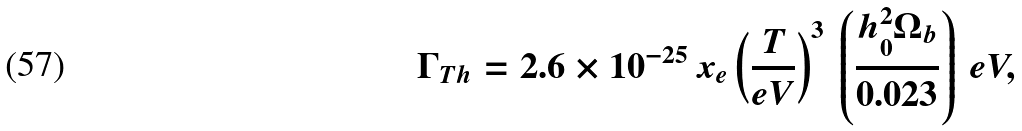Convert formula to latex. <formula><loc_0><loc_0><loc_500><loc_500>\Gamma _ { T h } = 2 . 6 \times 1 0 ^ { - 2 5 } \, x _ { e } \left ( \frac { T } { e V } \right ) ^ { 3 } \, \left ( \frac { h _ { 0 } ^ { 2 } \Omega _ { b } } { 0 . 0 2 3 } \right ) \, e V ,</formula> 